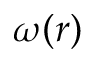Convert formula to latex. <formula><loc_0><loc_0><loc_500><loc_500>\omega ( r )</formula> 